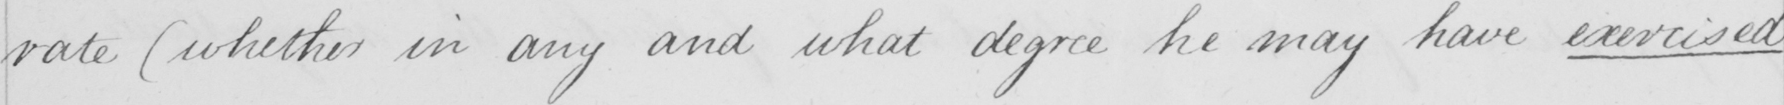What does this handwritten line say? rate  ( whether in any and what degree he may have exercised 